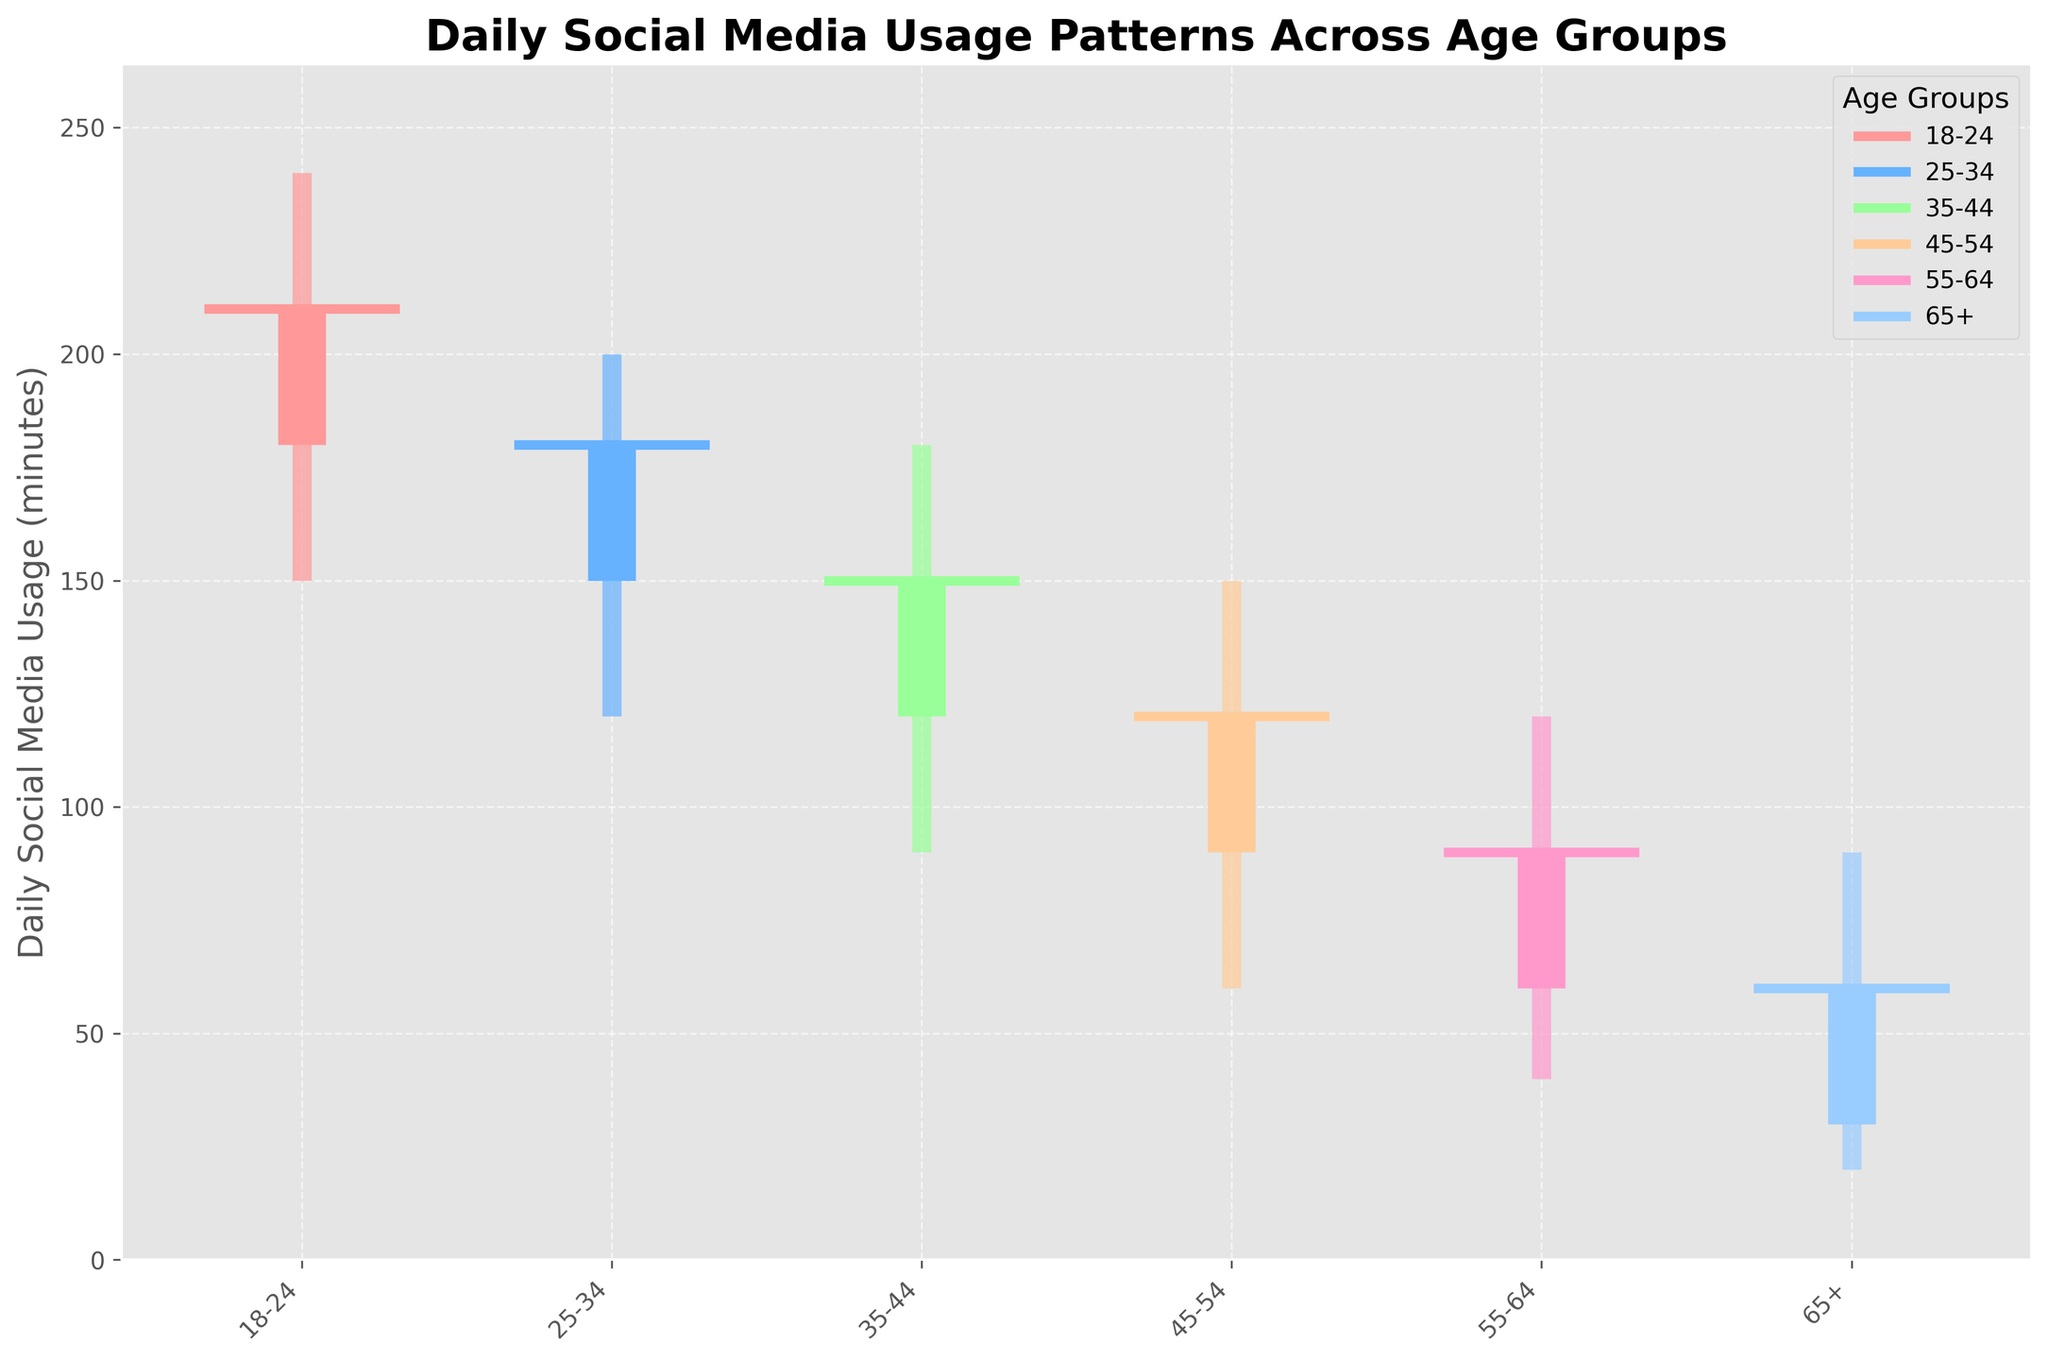What is the title of the figure? The title of the figure is displayed at the top and summarizes the main information presented in the chart.
Answer: Daily Social Media Usage Patterns Across Age Groups How many age groups are displayed in the figure? The x-axis labels represent different age groups. Count them to get the total number of age groups.
Answer: 6 Which age group has the highest range of daily social media usage? The range is the difference between the 'High' and 'Low' values for each age group. Identify the largest range.
Answer: 18-24 What is the difference between the highest and lowest daily social media usage for the age group 25-34? Subtract the 'Low' value from the 'High' value for the age group 25-34.
Answer: 80 Which age group has the smallest closing value for daily social media usage? Compare the 'Close' values across all age groups and identify the smallest one.
Answer: 65+ Is the closing value for the age group 35-44 higher than its opening value? Compare the 'Close' value to the 'Open' value for the age group 35-44 to see if it is higher.
Answer: No For the age group 45-54, how many minutes less is the opening value compared to the highest value? Subtract the 'Open' value from the 'High' value for the age group 45-54.
Answer: 60 Among all age groups, which one shows the highest closing value for daily social media usage? Compare the 'Close' values across all age groups and identify the highest one.
Answer: 18-24 What is the average opening value for daily social media usage across all age groups? Sum the 'Open' values for all age groups and divide by the total number of age groups.
Answer: 105 Which age group has a lower closing value compared to its opening value? Compare the 'Close' values to 'Open' values for each age group and identify those with a 'Close' value lower than 'Open'.
Answer: 35-44, 45-54, 65+ 